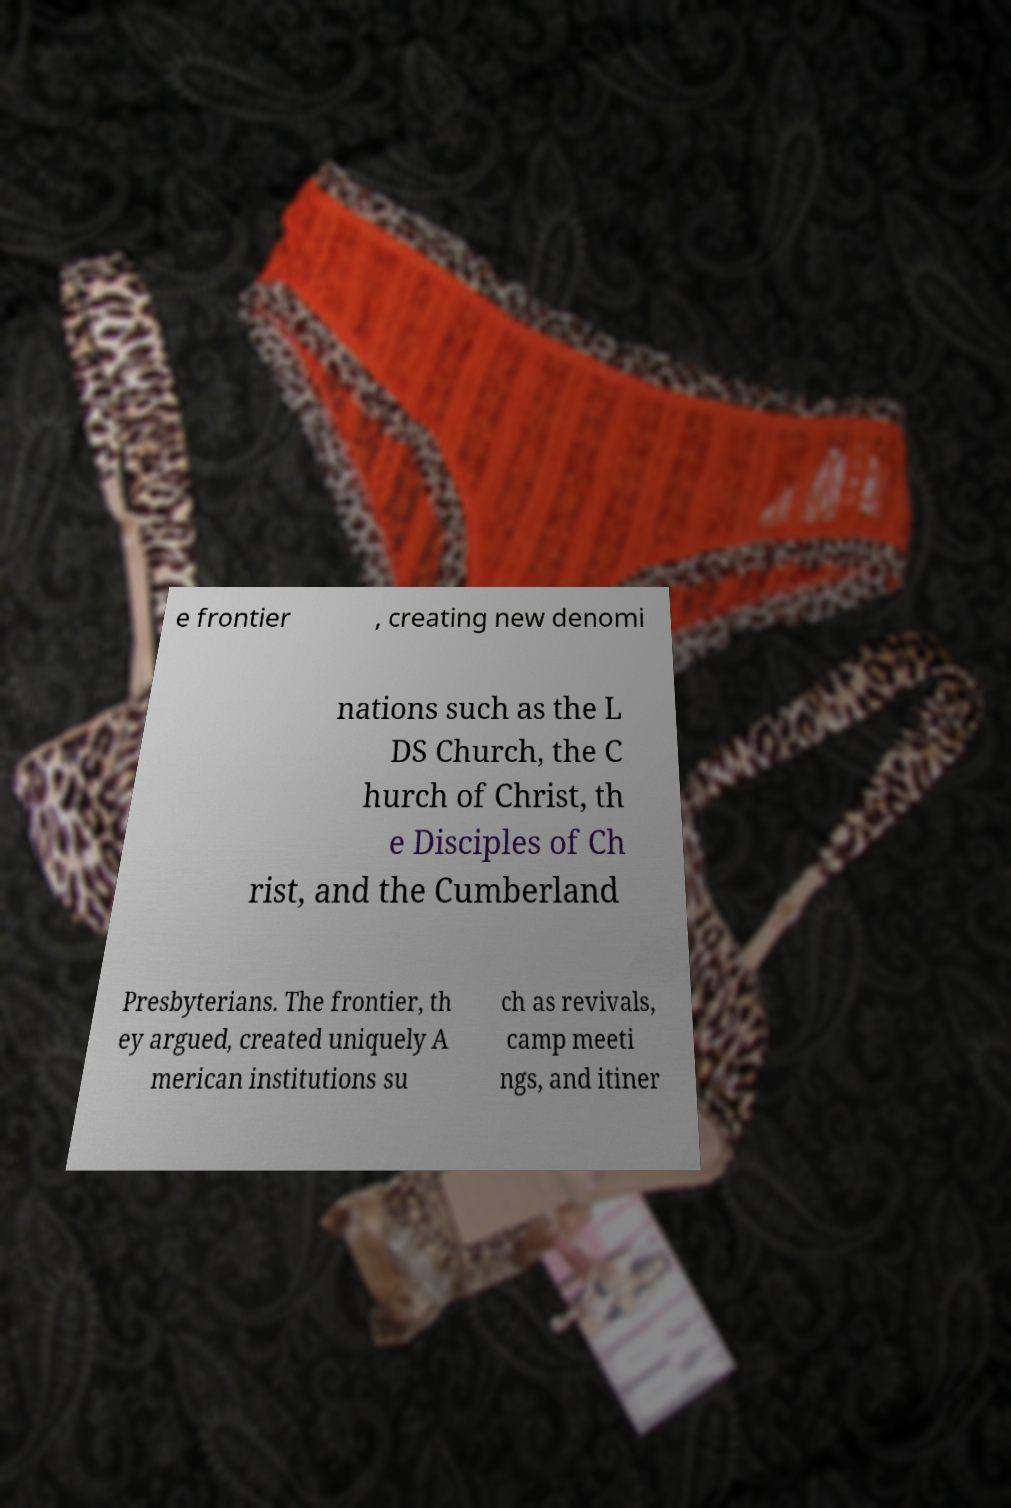Can you accurately transcribe the text from the provided image for me? e frontier , creating new denomi nations such as the L DS Church, the C hurch of Christ, th e Disciples of Ch rist, and the Cumberland Presbyterians. The frontier, th ey argued, created uniquely A merican institutions su ch as revivals, camp meeti ngs, and itiner 